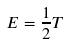Convert formula to latex. <formula><loc_0><loc_0><loc_500><loc_500>E = \frac { 1 } { 2 } T</formula> 